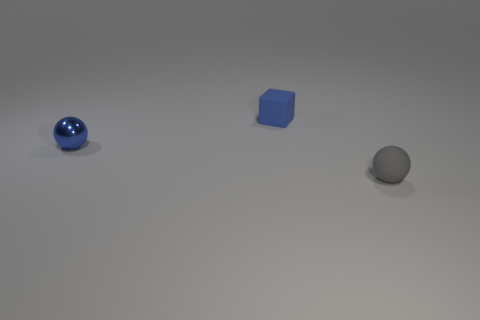Are there any other things that have the same material as the small blue sphere?
Keep it short and to the point. No. There is a blue metallic thing that is the same shape as the gray thing; what size is it?
Provide a short and direct response. Small. What number of objects are either metallic things that are to the left of the matte cube or tiny objects that are to the right of the blue matte thing?
Your answer should be compact. 2. Are there fewer small shiny spheres than cyan rubber balls?
Provide a short and direct response. No. Do the blue block and the sphere behind the tiny gray thing have the same size?
Provide a succinct answer. Yes. What number of rubber things are either cyan cylinders or small blue spheres?
Provide a succinct answer. 0. Is the number of tiny blue rubber objects greater than the number of purple matte balls?
Your answer should be very brief. Yes. The matte cube that is the same color as the metallic object is what size?
Provide a succinct answer. Small. What is the shape of the tiny rubber thing that is behind the tiny blue ball in front of the blue rubber thing?
Your answer should be very brief. Cube. Is there a blue metal ball behind the thing that is on the left side of the small matte object behind the small gray matte ball?
Keep it short and to the point. No. 